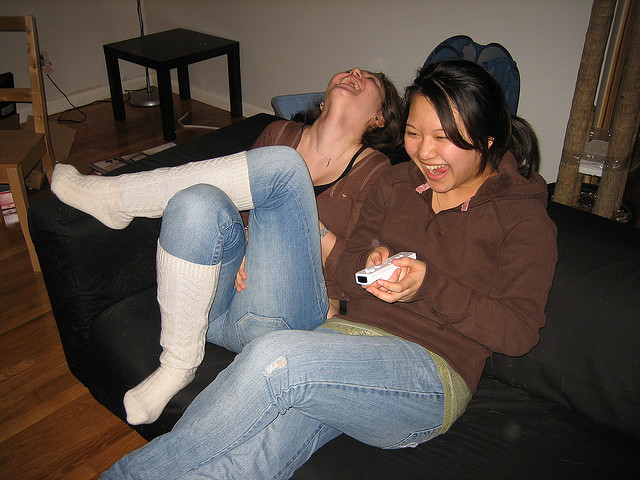<image>Which hand is holding the knife? There is no knife seen in the image. It is unclear which hand is holding the knife. What symbol is on the woman's sleeve? There is no symbol on the woman's sleeve. What kind of shoes is the woman wearing? The woman is not wearing shoes. It is also possible that she is wearing boots. Which hand is holding the knife? It is not clear which hand is holding the knife. There is no definite answer. What symbol is on the woman's sleeve? There is no symbol on the woman's sleeve. What kind of shoes is the woman wearing? I don't know what kind of shoes the woman is wearing. It is not clear from the given answers. 